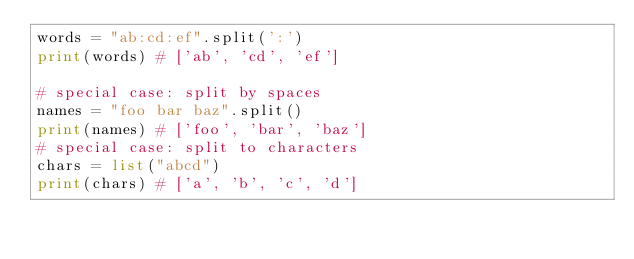<code> <loc_0><loc_0><loc_500><loc_500><_Python_>words = "ab:cd:ef".split(':')
print(words) # ['ab', 'cd', 'ef']

# special case: split by spaces
names = "foo bar baz".split()
print(names) # ['foo', 'bar', 'baz']
# special case: split to characters
chars = list("abcd")
print(chars) # ['a', 'b', 'c', 'd']</code> 